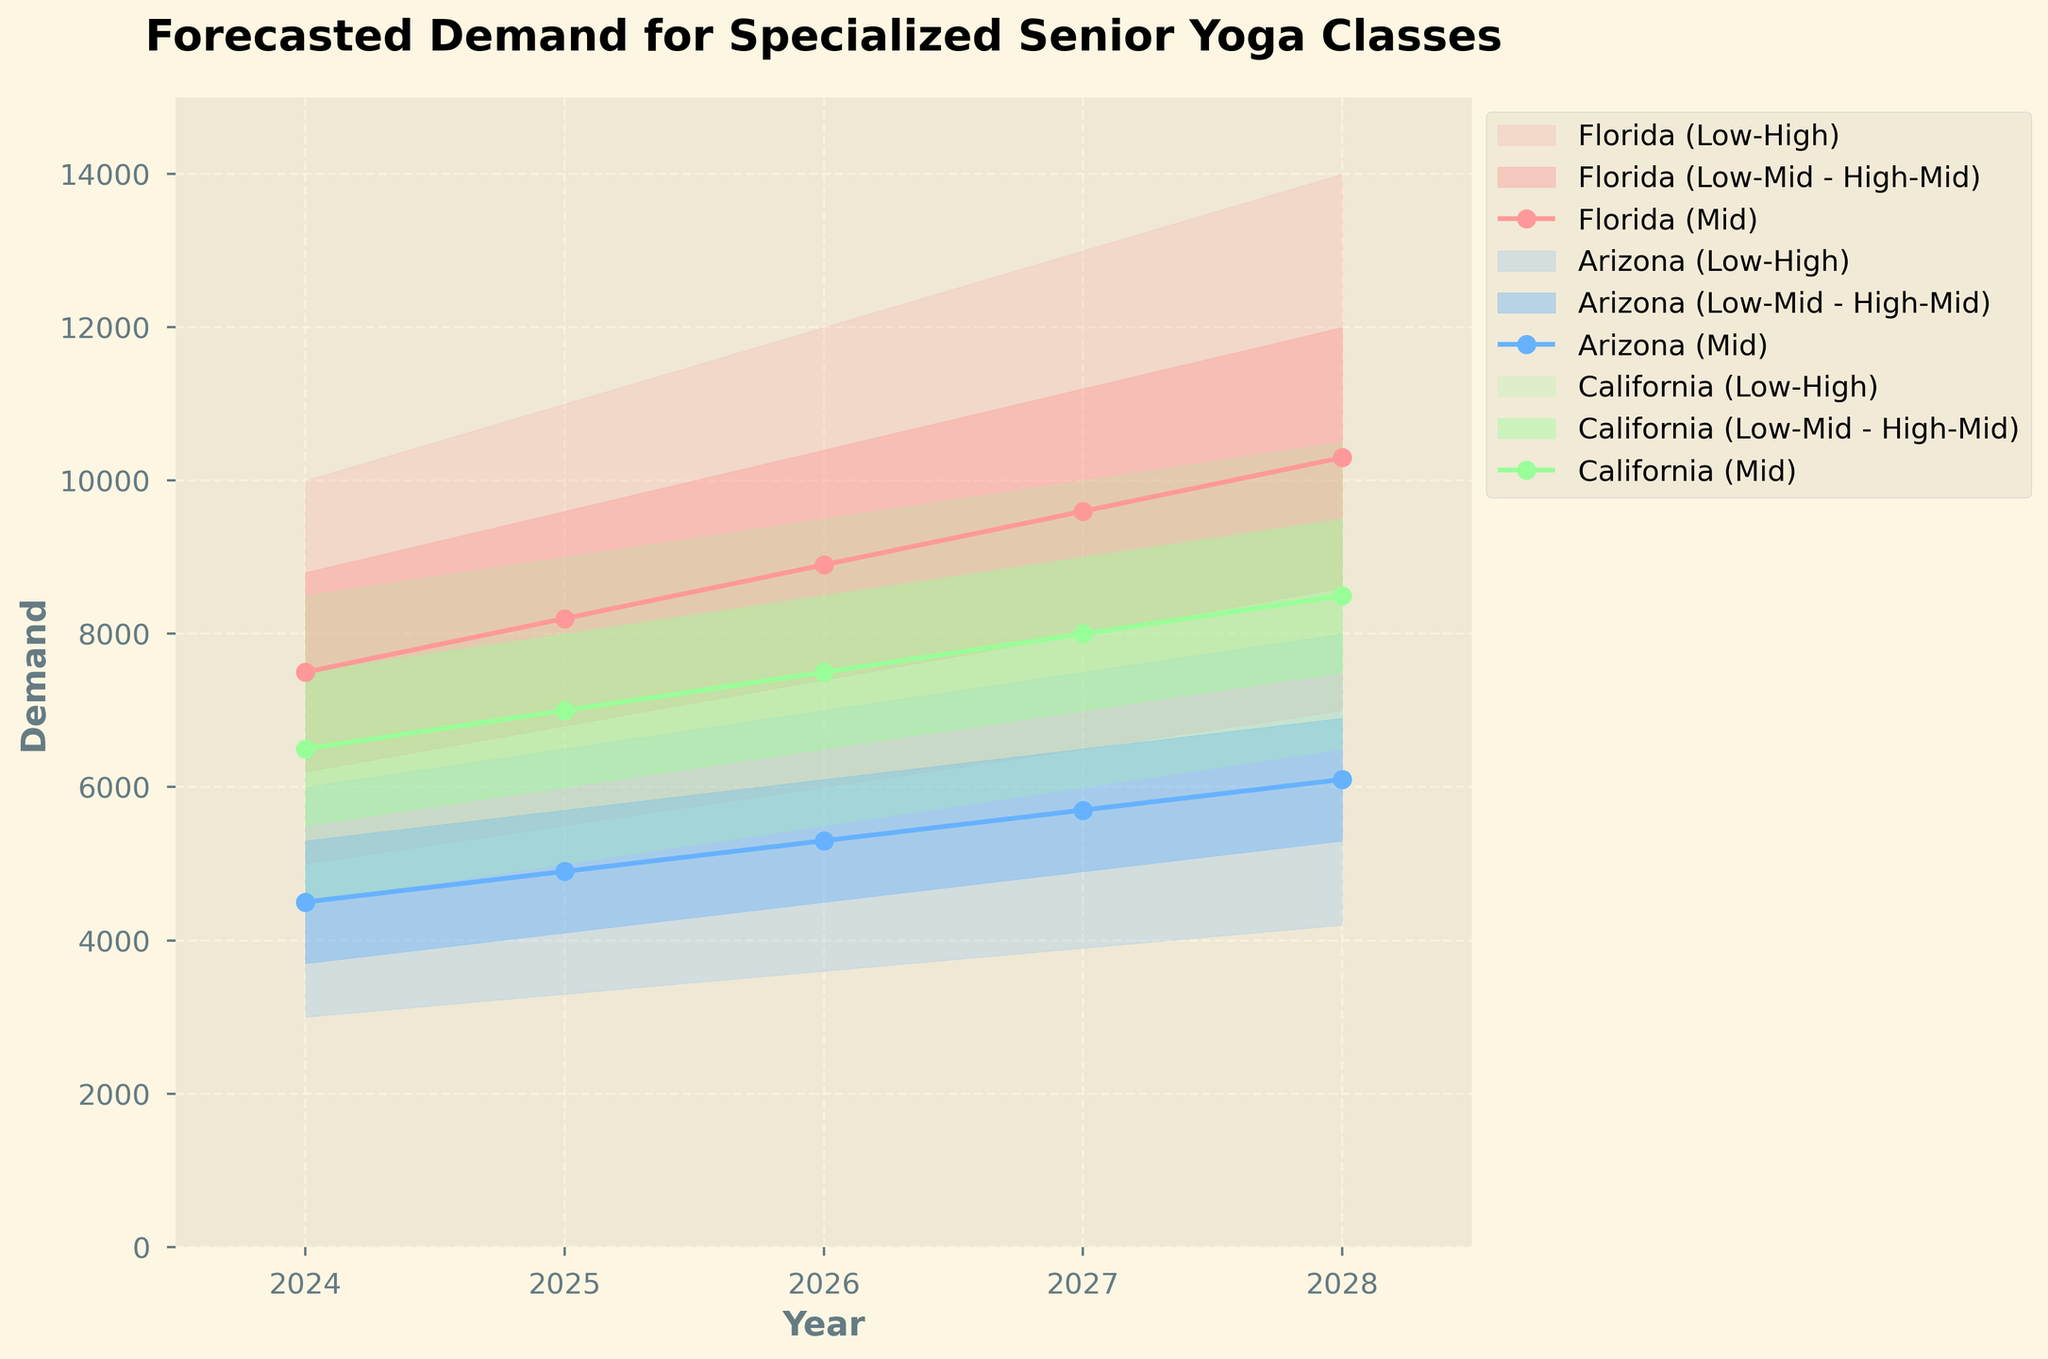What are the regions displayed in the fan chart? To determine the regions displayed in the fan chart, examine the legend or the labels in the plot. The chart displays lines and shaded areas for different regions, each with a unique color and label.
Answer: Florida, Arizona, California Which region is expected to have the highest mid estimate demand in 2028? Check the middle line within each shaded band for the year 2028. Compare the values of these mid estimates across all regions.
Answer: Florida What is the mid estimate demand for Arizona in 2026? Locate Arizona’s mid estimate line for the year 2026, which is represented as one of the data points. Observe the value on the y-axis corresponding to this point.
Answer: 5300 What is the range of demand estimates for California in 2027? For 2027, look at the shaded area for California. Identify the lower boundary (low estimate) and the upper boundary (high estimate) to determine the range.
Answer: 6000 to 10000 By how much is the high estimate for Florida expected to increase from 2024 to 2028? Note the high estimate values for Florida in both 2024 and 2028. Calculate the difference by subtracting the 2024 value from the 2028 value.
Answer: 4000 Compare the mid-median estimate increase for Florida versus Arizona from 2024 to 2028. Which region has a larger increase? Identify the mid estimates for both regions in 2024 and 2028. Subtract each region's initial value from the final value. Compare the results to see which is larger.
Answer: Florida Which region shows the highest variability in demand estimates in 2025? Variability can be indicated by the spread between the low estimate and high estimate for each region in 2025. Compare these spreads between the regions.
Answer: Florida Between 2024 and 2028, which year shows the smallest increase in forecasted demand for California based on mid estimates? Examine the mid estimates for California for each year between 2024 and 2028. Calculate the year-to-year increase and identify the smallest one.
Answer: 2025-2026 What general trend do the forecasted demands follow across all regions from 2024 to 2028? Observe the overall direction of the lines for the mid estimates across all years and regions. Note whether they are all increasing, decreasing, or remaining stable.
Answer: Increasing Do any regions have overlapping high and low estimate ranges in any given year? Check the shaded areas across the same years for different regions to see if any high range of one overlaps with the low range of another.
Answer: No 